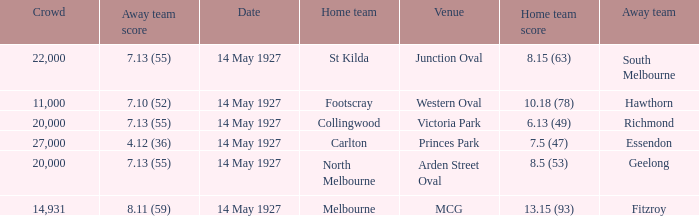On what date does Essendon play as the away team? 14 May 1927. 